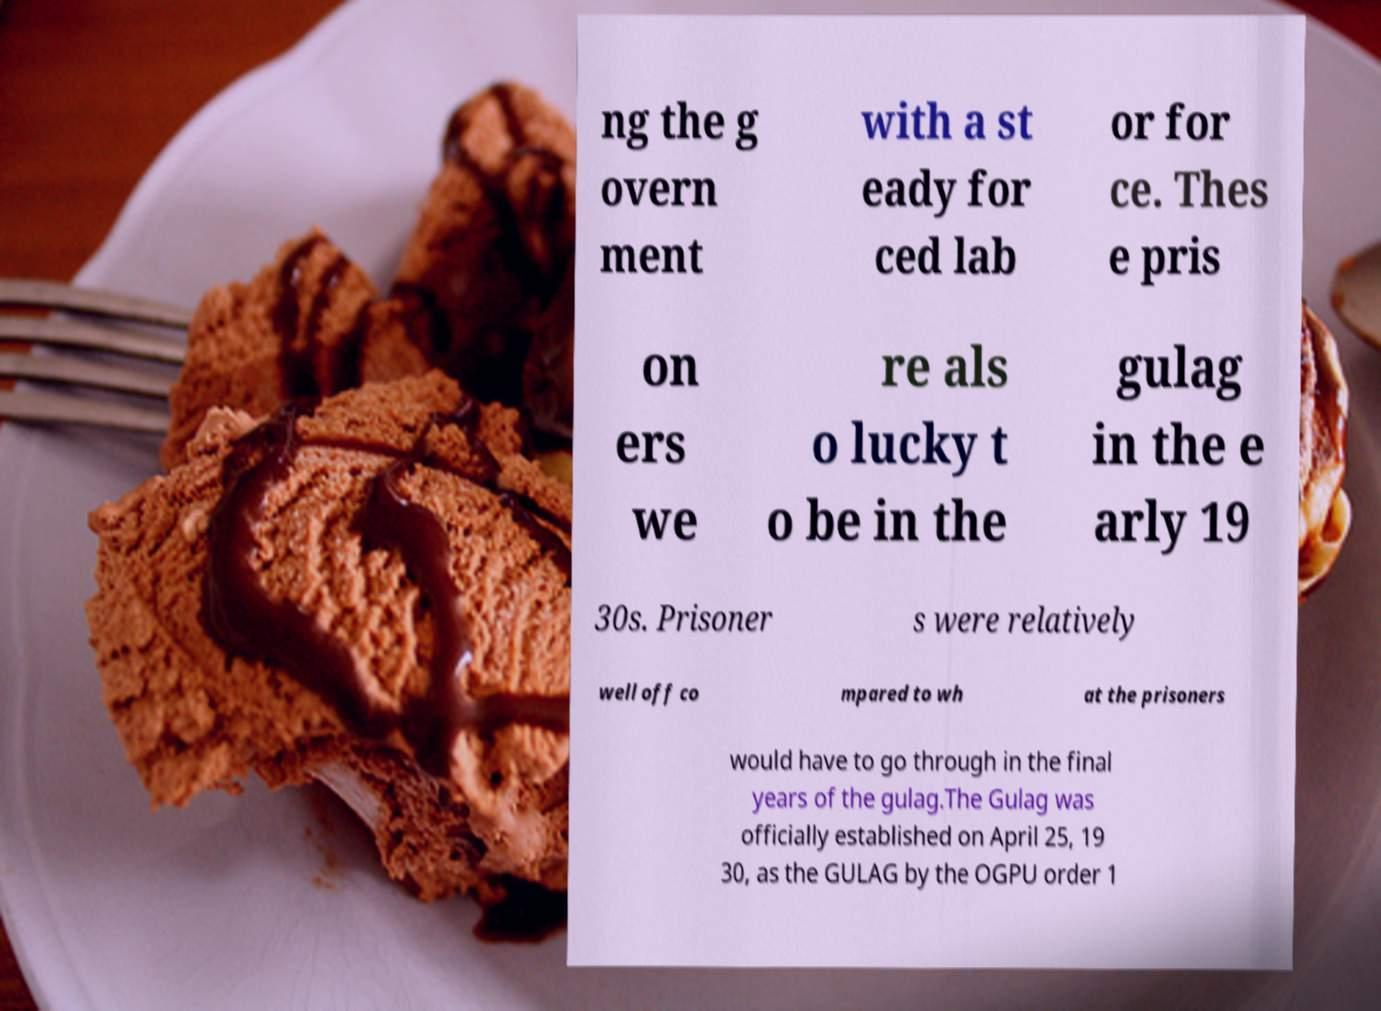Can you read and provide the text displayed in the image?This photo seems to have some interesting text. Can you extract and type it out for me? ng the g overn ment with a st eady for ced lab or for ce. Thes e pris on ers we re als o lucky t o be in the gulag in the e arly 19 30s. Prisoner s were relatively well off co mpared to wh at the prisoners would have to go through in the final years of the gulag.The Gulag was officially established on April 25, 19 30, as the GULAG by the OGPU order 1 